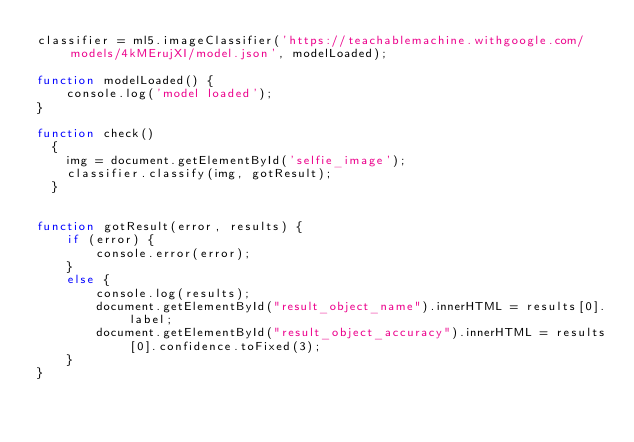Convert code to text. <code><loc_0><loc_0><loc_500><loc_500><_JavaScript_>classifier = ml5.imageClassifier('https://teachablemachine.withgoogle.com/models/4kMErujXI/model.json', modelLoaded);

function modelLoaded() {
    console.log('model loaded');
}

function check()
  {
    img = document.getElementById('selfie_image');
    classifier.classify(img, gotResult);
  }


function gotResult(error, results) {
    if (error) {
        console.error(error);
    }
    else {
        console.log(results);
        document.getElementById("result_object_name").innerHTML = results[0].label;
        document.getElementById("result_object_accuracy").innerHTML = results[0].confidence.toFixed(3);
    }
}</code> 